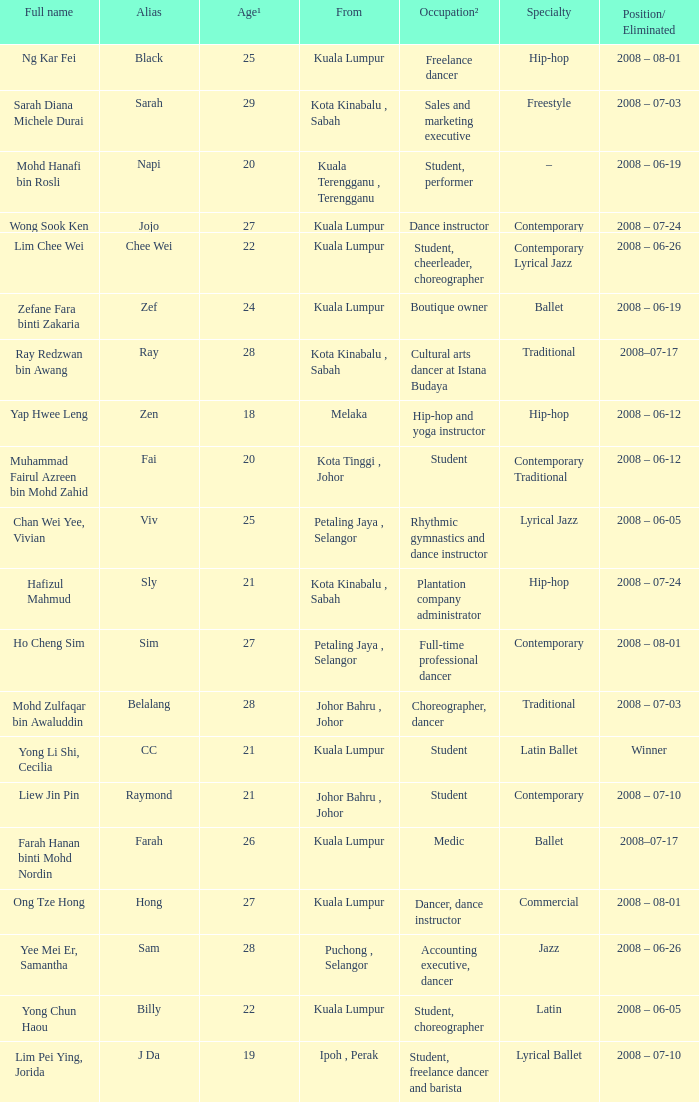What is Position/ Eliminated, when From is "Kuala Lumpur", and when Specialty is "Contemporary Lyrical Jazz"? 2008 – 06-26. 